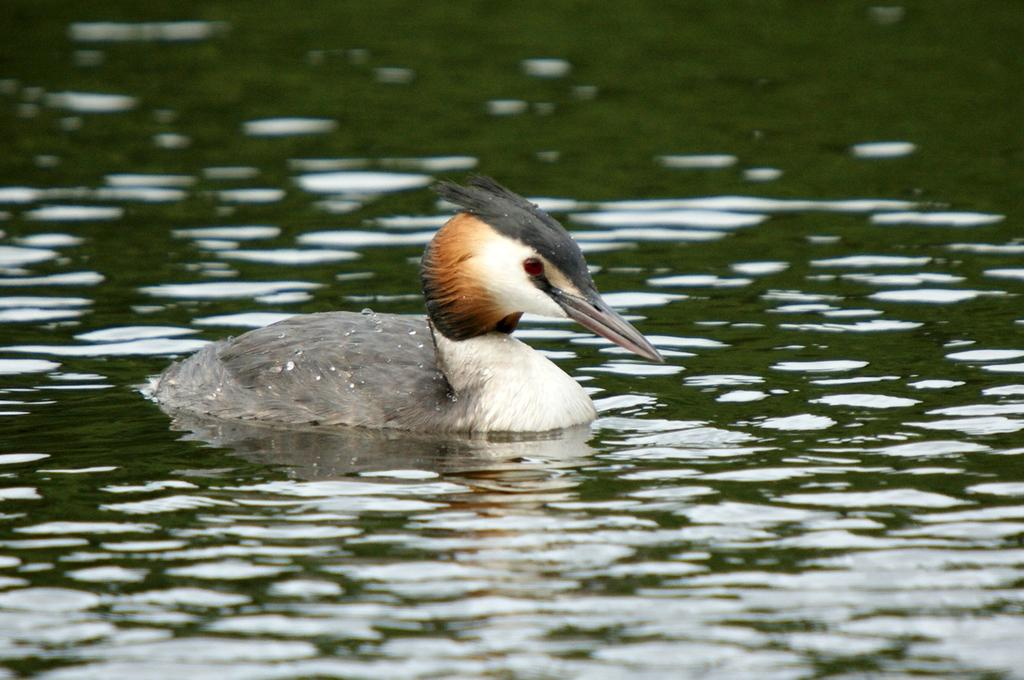What animal can be seen in the image? There is a duck in the image. What is the duck doing in the image? The duck is swimming in the water. What type of ring can be seen on the duck's knee in the image? There is no ring or knee visible on the duck in the image; it is simply swimming in the water. 